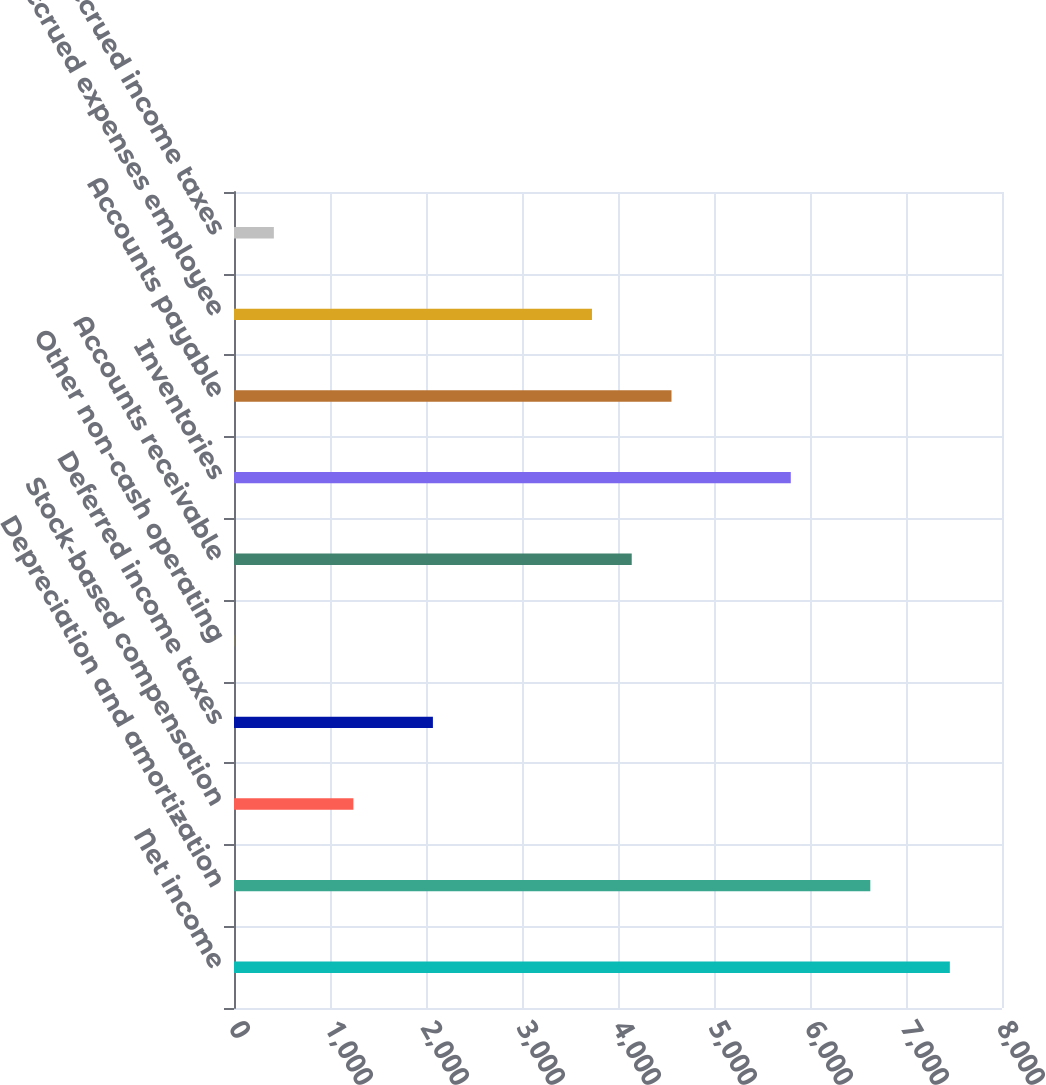Convert chart. <chart><loc_0><loc_0><loc_500><loc_500><bar_chart><fcel>Net income<fcel>Depreciation and amortization<fcel>Stock-based compensation<fcel>Deferred income taxes<fcel>Other non-cash operating<fcel>Accounts receivable<fcel>Inventories<fcel>Accounts payable<fcel>Accrued expenses employee<fcel>Accrued income taxes<nl><fcel>7456.6<fcel>6628.2<fcel>1243.6<fcel>2072<fcel>1<fcel>4143<fcel>5799.8<fcel>4557.2<fcel>3728.8<fcel>415.2<nl></chart> 